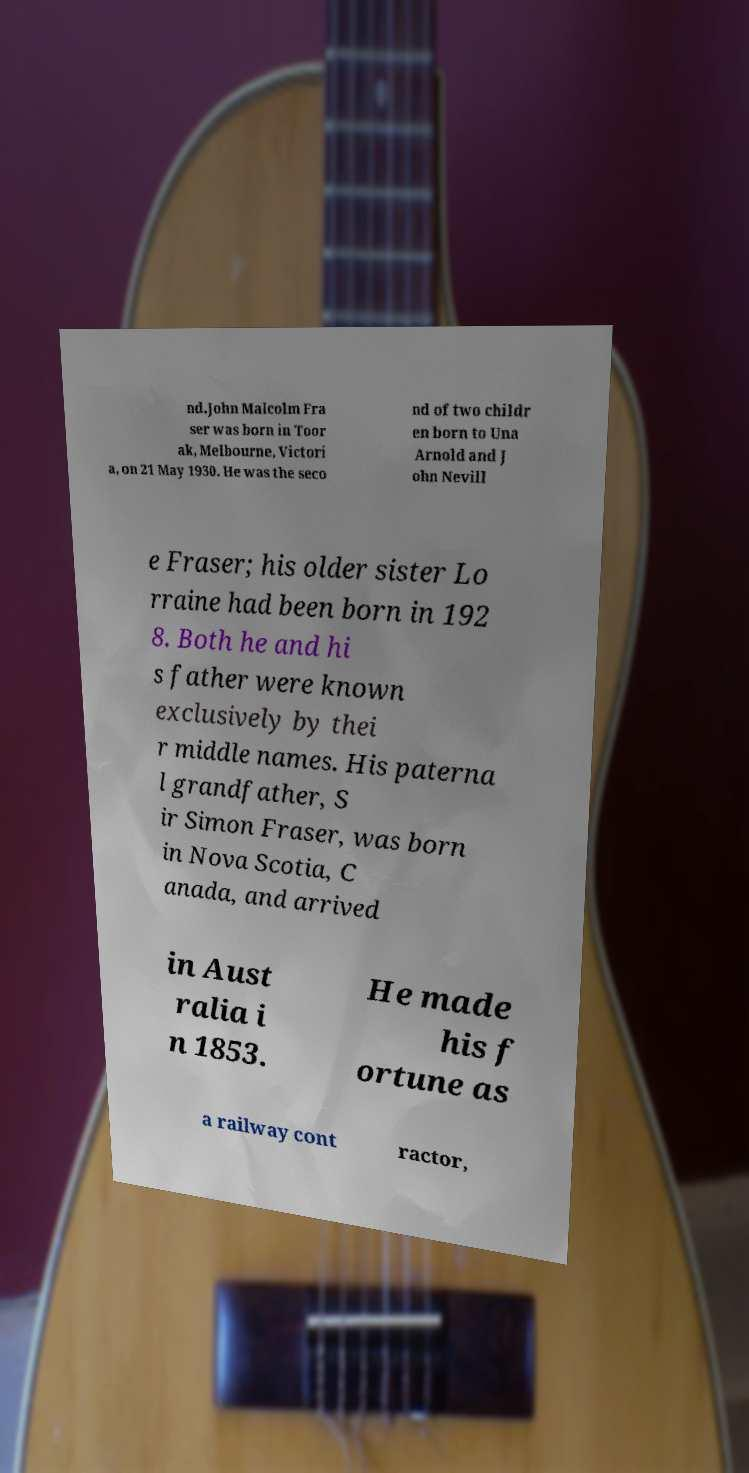Please identify and transcribe the text found in this image. nd.John Malcolm Fra ser was born in Toor ak, Melbourne, Victori a, on 21 May 1930. He was the seco nd of two childr en born to Una Arnold and J ohn Nevill e Fraser; his older sister Lo rraine had been born in 192 8. Both he and hi s father were known exclusively by thei r middle names. His paterna l grandfather, S ir Simon Fraser, was born in Nova Scotia, C anada, and arrived in Aust ralia i n 1853. He made his f ortune as a railway cont ractor, 